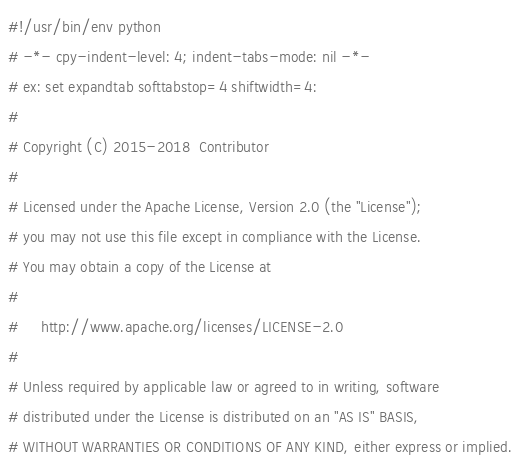Convert code to text. <code><loc_0><loc_0><loc_500><loc_500><_Python_>#!/usr/bin/env python
# -*- cpy-indent-level: 4; indent-tabs-mode: nil -*-
# ex: set expandtab softtabstop=4 shiftwidth=4:
#
# Copyright (C) 2015-2018  Contributor
#
# Licensed under the Apache License, Version 2.0 (the "License");
# you may not use this file except in compliance with the License.
# You may obtain a copy of the License at
#
#     http://www.apache.org/licenses/LICENSE-2.0
#
# Unless required by applicable law or agreed to in writing, software
# distributed under the License is distributed on an "AS IS" BASIS,
# WITHOUT WARRANTIES OR CONDITIONS OF ANY KIND, either express or implied.</code> 